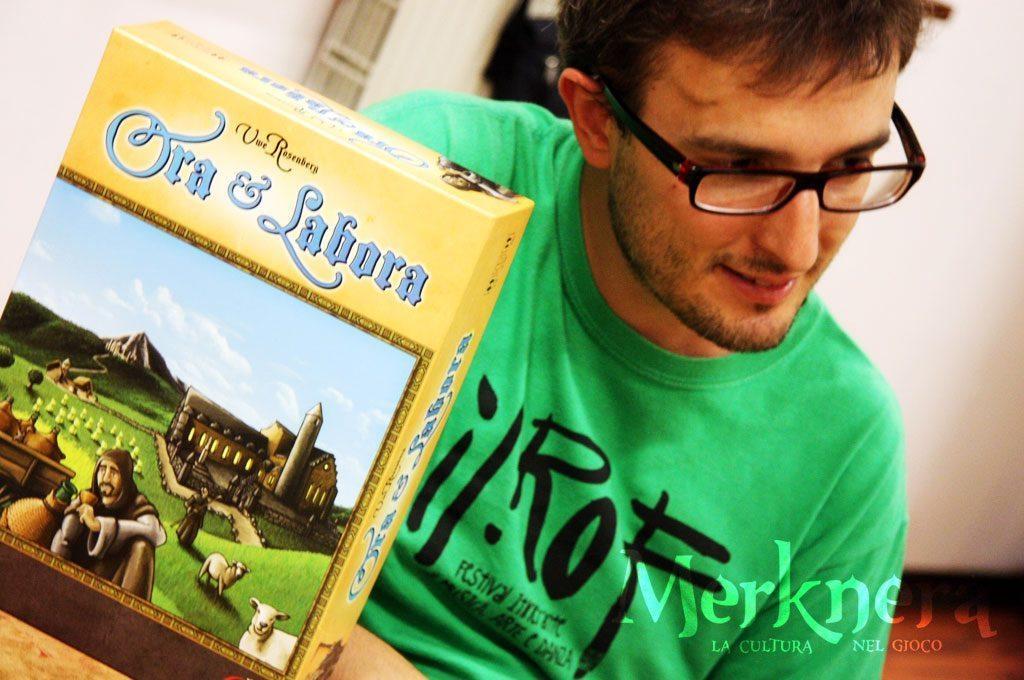How would you summarize this image in a sentence or two? In this image we can see a man wearing a green shirt. In the background there is a wall. On the left we can see a carton placed on the table. 